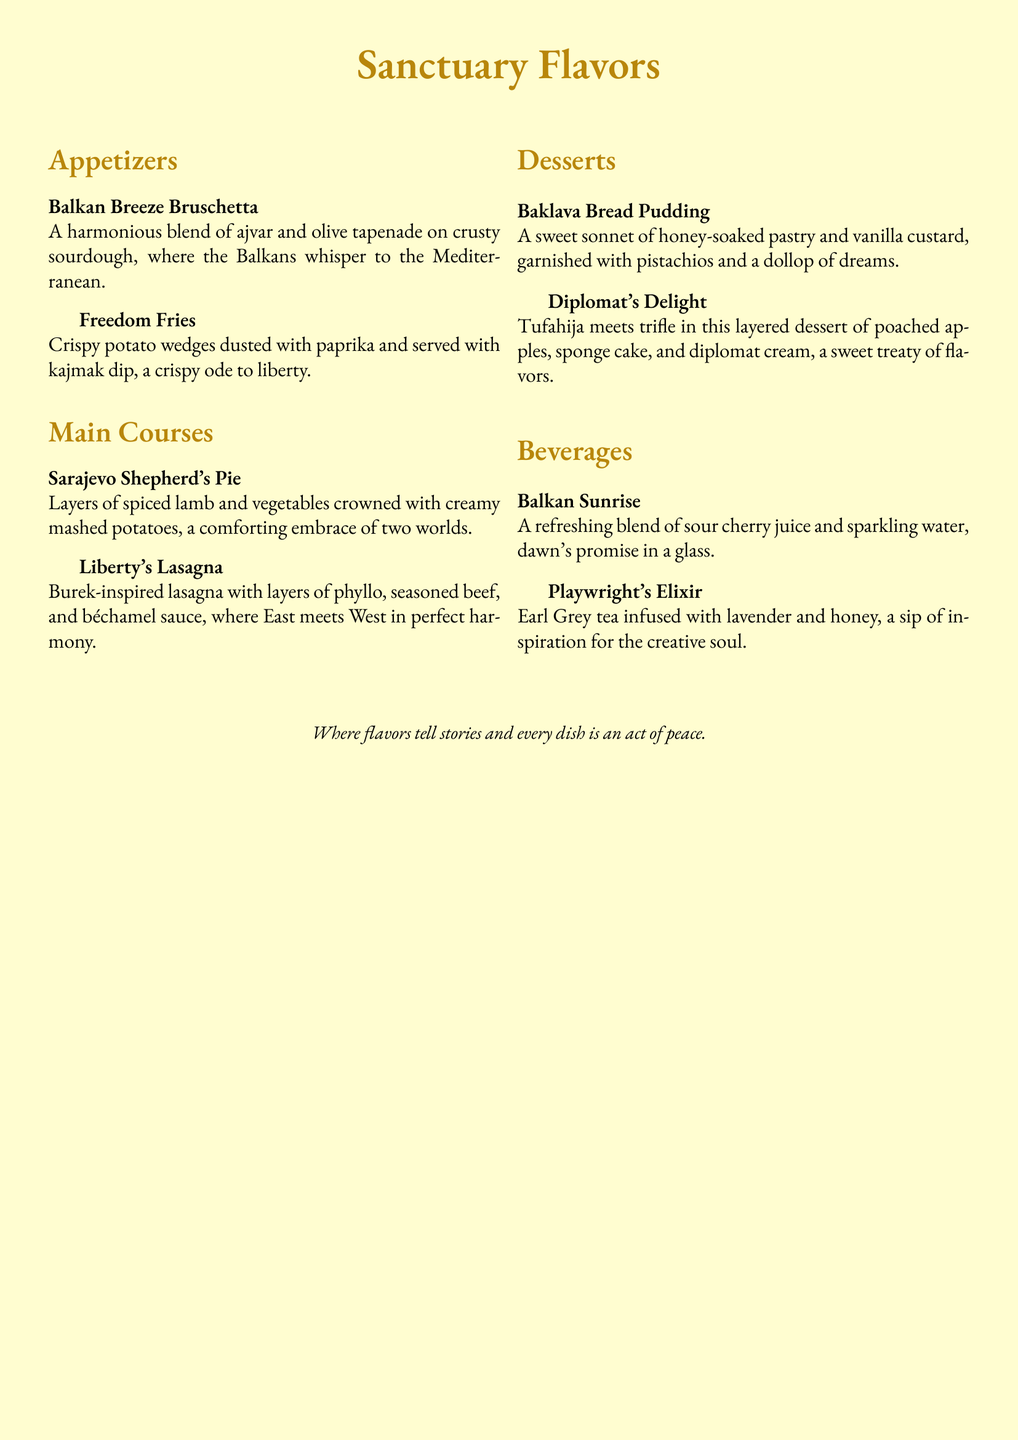what is the name of the restaurant menu? The title of the menu is prominently displayed at the top of the document.
Answer: Sanctuary Flavors how many sections are in the menu? The menu is divided into multiple sections including appetizers, main courses, desserts, and beverages.
Answer: 4 what is the main ingredient in the Sarajevo Shepherd's Pie? The name of the dish suggests it features a specific type of meat which is indicated in the description.
Answer: spiced lamb which drink is described as a "sip of inspiration for the creative soul"? The drink description uses poetic language to indicate its purpose as a source of inspiration.
Answer: Playwright's Elixir what are the ingredients in the Baklava Bread Pudding? The description lists the elements that make up this dessert.
Answer: honey-soaked pastry and vanilla custard what is the flavor profile of the Balkan Sunrise? The description characterizes this beverage by mentioning its main components.
Answer: sour cherry juice and sparkling water how is the Liberty's Lasagna inspired by traditional dishes? The description explains the influence of a specific dish on this fusion lasagna.
Answer: Burek-inspired what type of cuisine does the Freedom Fries represent? The dish's name and ingredients hint at the geographic or cultural background it draws from.
Answer: Balkan what garnish is used on the Diplomat's Delight? The dessert description specifies a particular topping that adds to its presentation and flavor.
Answer: diplomat cream 